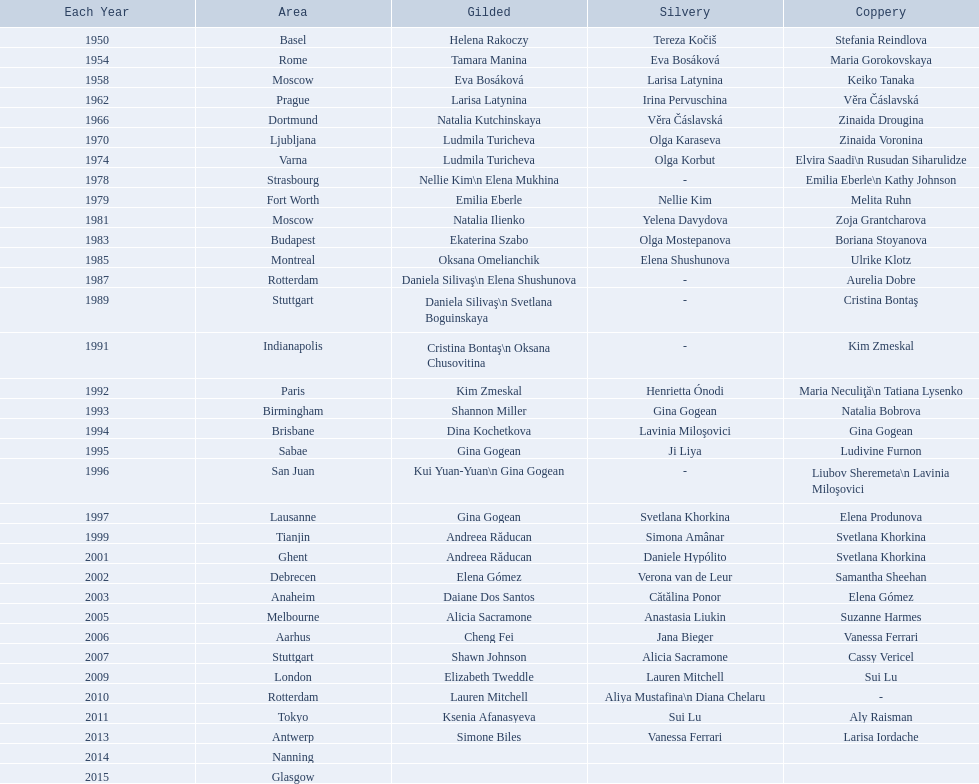How long is the time between the times the championship was held in moscow? 23 years. 